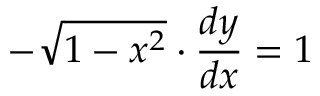<formula> <loc_0><loc_0><loc_500><loc_500>- { \sqrt { 1 - x ^ { 2 } } } \cdot { \frac { d y } { d x } } = 1</formula> 